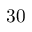<formula> <loc_0><loc_0><loc_500><loc_500>3 0</formula> 